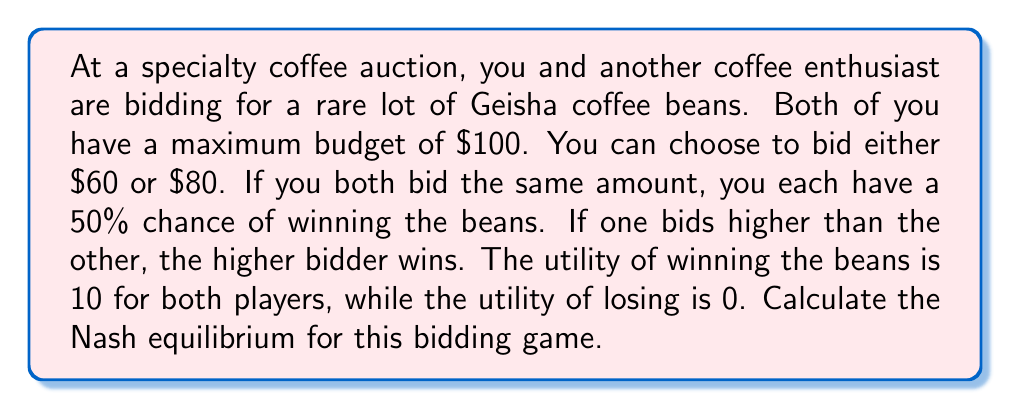Help me with this question. Let's approach this step-by-step:

1) First, we need to construct the payoff matrix for this game. Let's denote the strategies as "Bid 60" and "Bid 80" for each player.

2) The payoff matrix will look like this:

   $$
   \begin{array}{c|c|c}
    & \text{Bid 60} & \text{Bid 80} \\
   \hline
   \text{Bid 60} & (5-60, 5-60) & (0, 10-80) \\
   \hline
   \text{Bid 80} & (10-80, 0) & (5-80, 5-80) \\
   \end{array}
   $$

   Where the first number in each cell represents the payoff for the row player, and the second number represents the payoff for the column player.

3) Simplifying the payoffs:

   $$
   \begin{array}{c|c|c}
    & \text{Bid 60} & \text{Bid 80} \\
   \hline
   \text{Bid 60} & (-55, -55) & (0, -70) \\
   \hline
   \text{Bid 80} & (-70, 0) & (-75, -75) \\
   \end{array}
   $$

4) To find the Nash equilibrium, we need to check if any player has an incentive to deviate from their strategy given the other player's strategy.

5) If Player 2 bids 60:
   - If Player 1 bids 60, they get -55
   - If Player 1 bids 80, they get -70
   Player 1 prefers to bid 60

6) If Player 2 bids 80:
   - If Player 1 bids 60, they get 0
   - If Player 1 bids 80, they get -75
   Player 1 prefers to bid 60

7) The same logic applies to Player 2 due to symmetry.

8) Therefore, neither player has an incentive to deviate from bidding 60 when the other player bids 60.

Thus, the Nash equilibrium for this game is (Bid 60, Bid 60).
Answer: The Nash equilibrium for this coffee bean auction game is (Bid 60, Bid 60). 